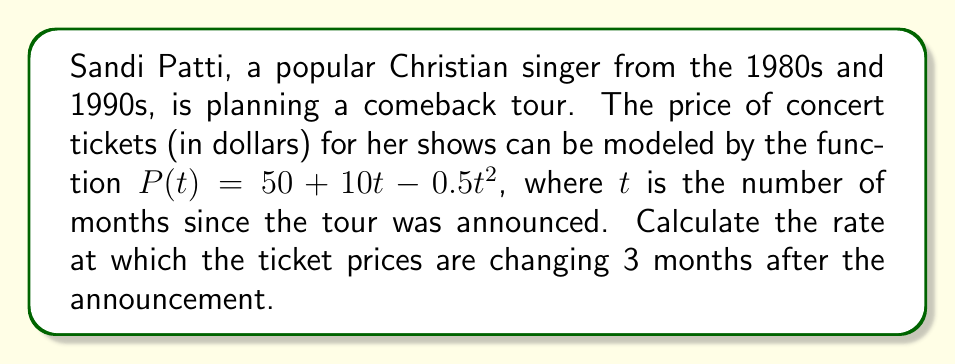Show me your answer to this math problem. To solve this problem, we need to follow these steps:

1. Understand the given function:
   $P(t) = 50 + 10t - 0.5t^2$
   This function represents the price of tickets (P) in terms of time (t) in months.

2. To find the rate of change, we need to find the derivative of the function:
   $$\frac{dP}{dt} = \frac{d}{dt}(50 + 10t - 0.5t^2)$$

3. Using the power rule and constant rule of differentiation:
   $$\frac{dP}{dt} = 0 + 10 - 0.5(2t)$$
   $$\frac{dP}{dt} = 10 - t$$

4. Now, we need to find the rate of change at 3 months after the announcement:
   Substitute $t = 3$ into the derivative function:
   $$\frac{dP}{dt}\bigg|_{t=3} = 10 - 3 = 7$$

5. Interpret the result:
   The rate of change is 7 dollars per month at $t = 3$ months.
Answer: The rate at which ticket prices are changing 3 months after the announcement is $7$ dollars per month. 